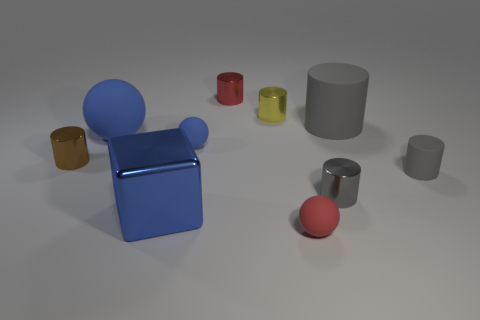How is the lighting in the image affecting the appearance of the objects? The lighting creates a soft shadow on the side of the objects opposite to the light source, enhancing their three-dimensional shapes and giving depth to the image. Does the light reveal the texture of any objects? Yes, the light particularly reveals the reflective texture of the blue cube and the silver cylinder, showcasing a smooth, shiny surface. 